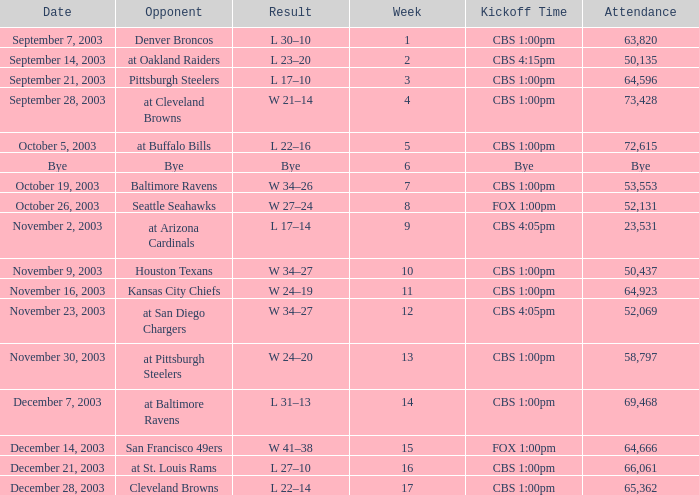What was the kickoff time on week 1? CBS 1:00pm. 